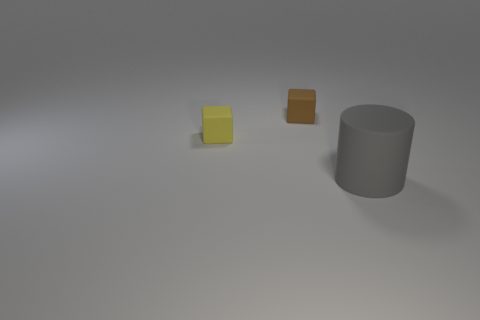Subtract 1 cylinders. How many cylinders are left? 0 Add 1 brown cubes. How many objects exist? 4 Add 3 big cylinders. How many big cylinders are left? 4 Add 1 brown matte objects. How many brown matte objects exist? 2 Subtract 0 purple cylinders. How many objects are left? 3 Subtract all blocks. How many objects are left? 1 Subtract all purple cylinders. Subtract all purple cubes. How many cylinders are left? 1 Subtract all red spheres. How many yellow blocks are left? 1 Subtract all tiny matte objects. Subtract all yellow cubes. How many objects are left? 0 